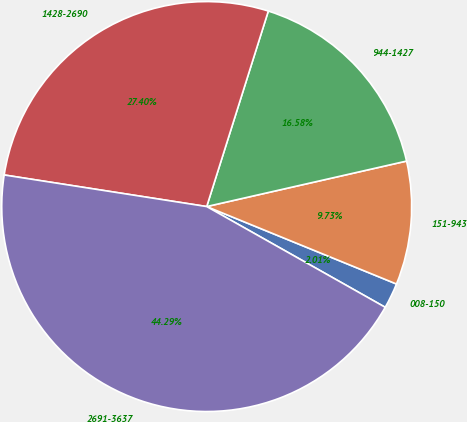Convert chart to OTSL. <chart><loc_0><loc_0><loc_500><loc_500><pie_chart><fcel>008-150<fcel>151-943<fcel>944-1427<fcel>1428-2690<fcel>2691-3637<nl><fcel>2.01%<fcel>9.73%<fcel>16.58%<fcel>27.4%<fcel>44.29%<nl></chart> 